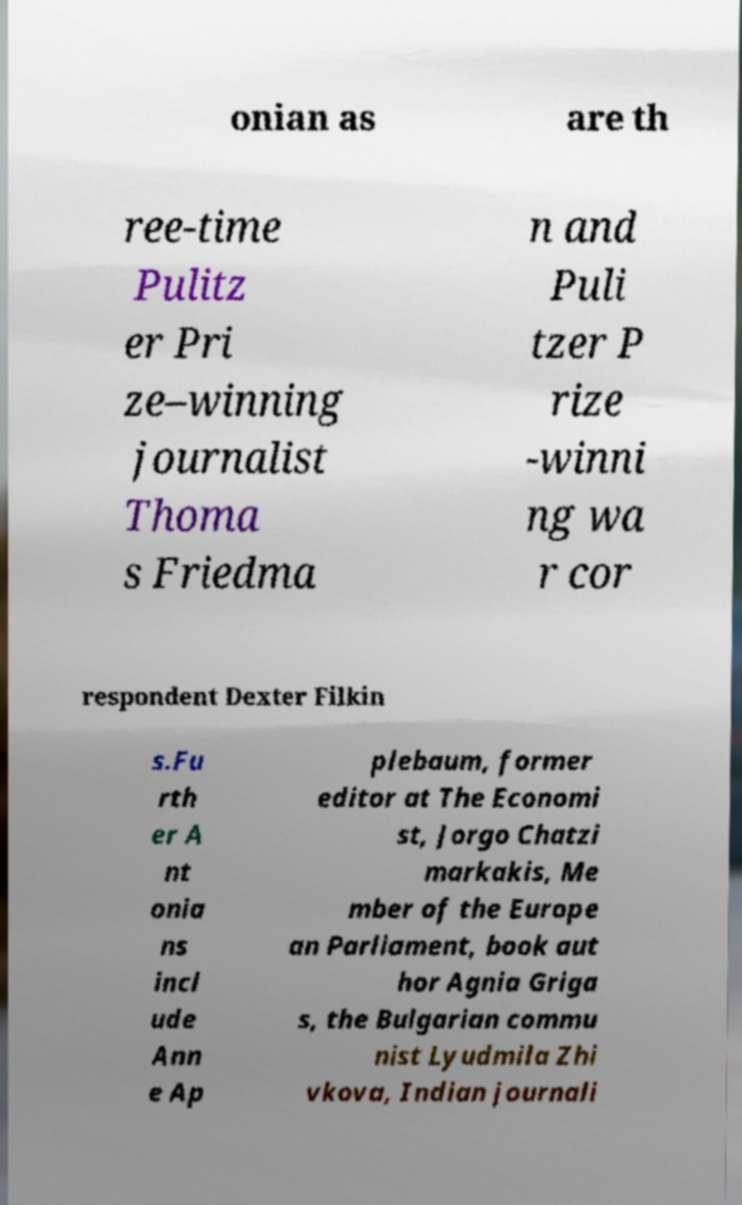Could you extract and type out the text from this image? onian as are th ree-time Pulitz er Pri ze–winning journalist Thoma s Friedma n and Puli tzer P rize -winni ng wa r cor respondent Dexter Filkin s.Fu rth er A nt onia ns incl ude Ann e Ap plebaum, former editor at The Economi st, Jorgo Chatzi markakis, Me mber of the Europe an Parliament, book aut hor Agnia Griga s, the Bulgarian commu nist Lyudmila Zhi vkova, Indian journali 